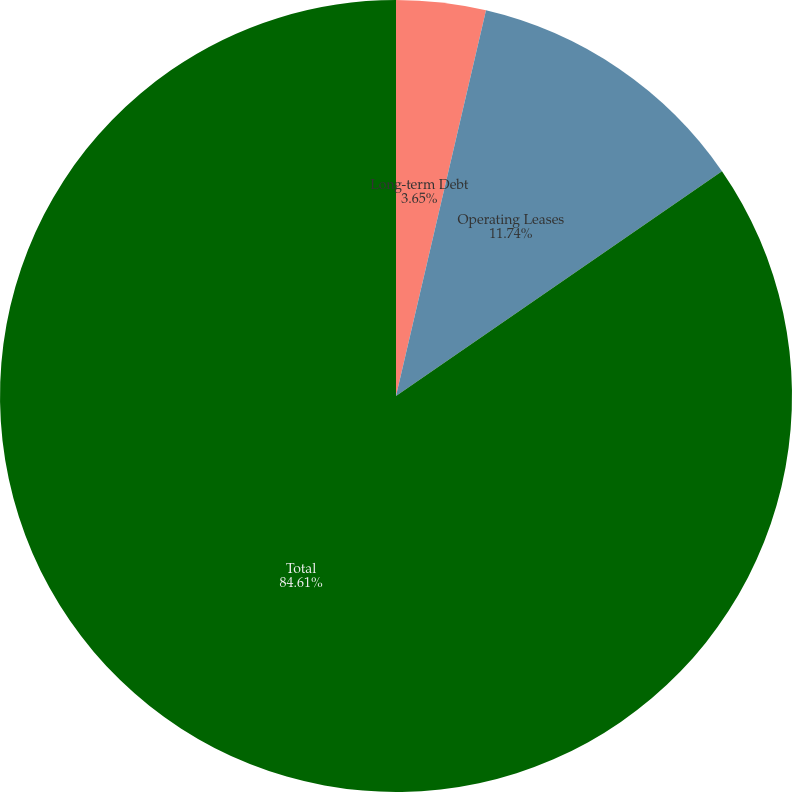<chart> <loc_0><loc_0><loc_500><loc_500><pie_chart><fcel>Long-term Debt<fcel>Operating Leases<fcel>Total<nl><fcel>3.65%<fcel>11.74%<fcel>84.61%<nl></chart> 